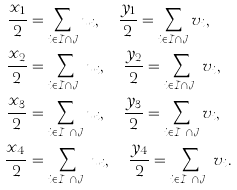<formula> <loc_0><loc_0><loc_500><loc_500>\frac { x _ { 1 } } { 2 } & = \sum _ { i \in \mathcal { I } \cap \mathcal { J } } u _ { i } , \quad \frac { y _ { 1 } } { 2 } = \sum _ { i \in \mathcal { I } \cap \mathcal { J } } v _ { i } , \\ \frac { x _ { 2 } } { 2 } & = \sum _ { i \in \mathcal { I } \cap \mathcal { J } ^ { c } } u _ { i } , \quad \frac { y _ { 2 } } { 2 } = \sum _ { i \in \mathcal { I } \cap \mathcal { J } ^ { c } } v _ { i } , \\ \frac { x _ { 3 } } { 2 } & = \sum _ { i \in \mathcal { I } ^ { c } \cap \mathcal { J } } u _ { i } , \quad \frac { y _ { 3 } } { 2 } = \sum _ { i \in \mathcal { I } ^ { c } \cap \mathcal { J } } v _ { i } , \\ \frac { x _ { 4 } } { 2 } & = \sum _ { i \in \mathcal { I } ^ { c } \cap \mathcal { J } ^ { c } } u _ { i } , \quad \frac { y _ { 4 } } { 2 } = \sum _ { i \in \mathcal { I } ^ { c } \cap \mathcal { J } ^ { c } } v _ { i } .</formula> 